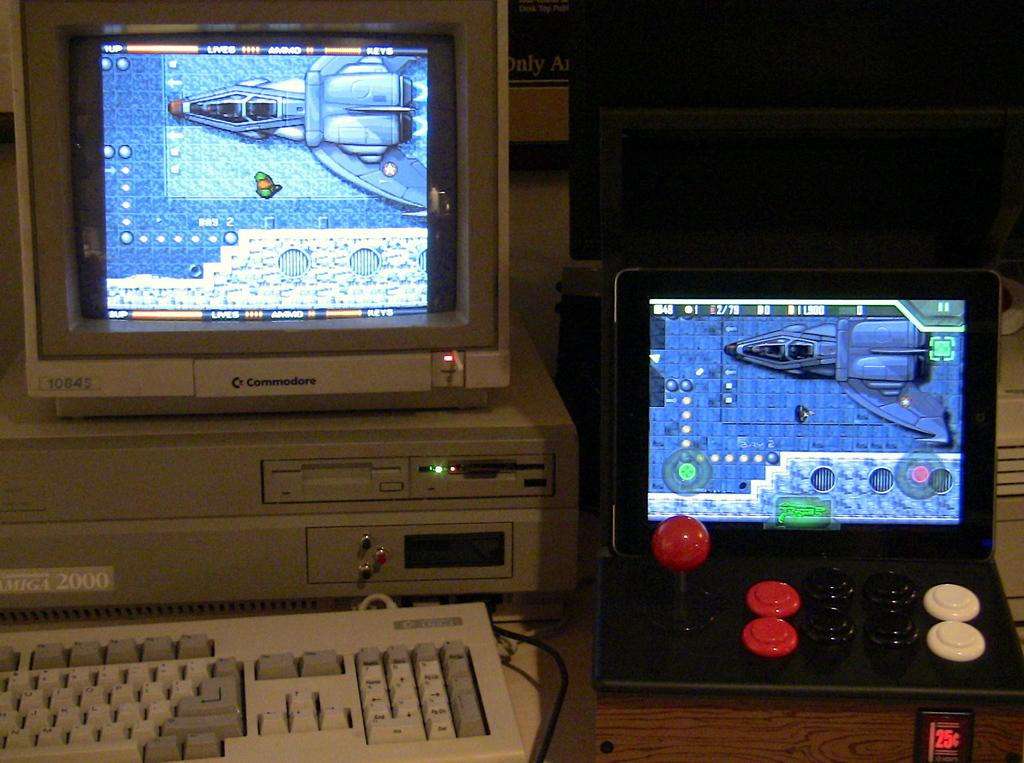<image>
Summarize the visual content of the image. The monitor on top of a old computer is labeled commodore. 